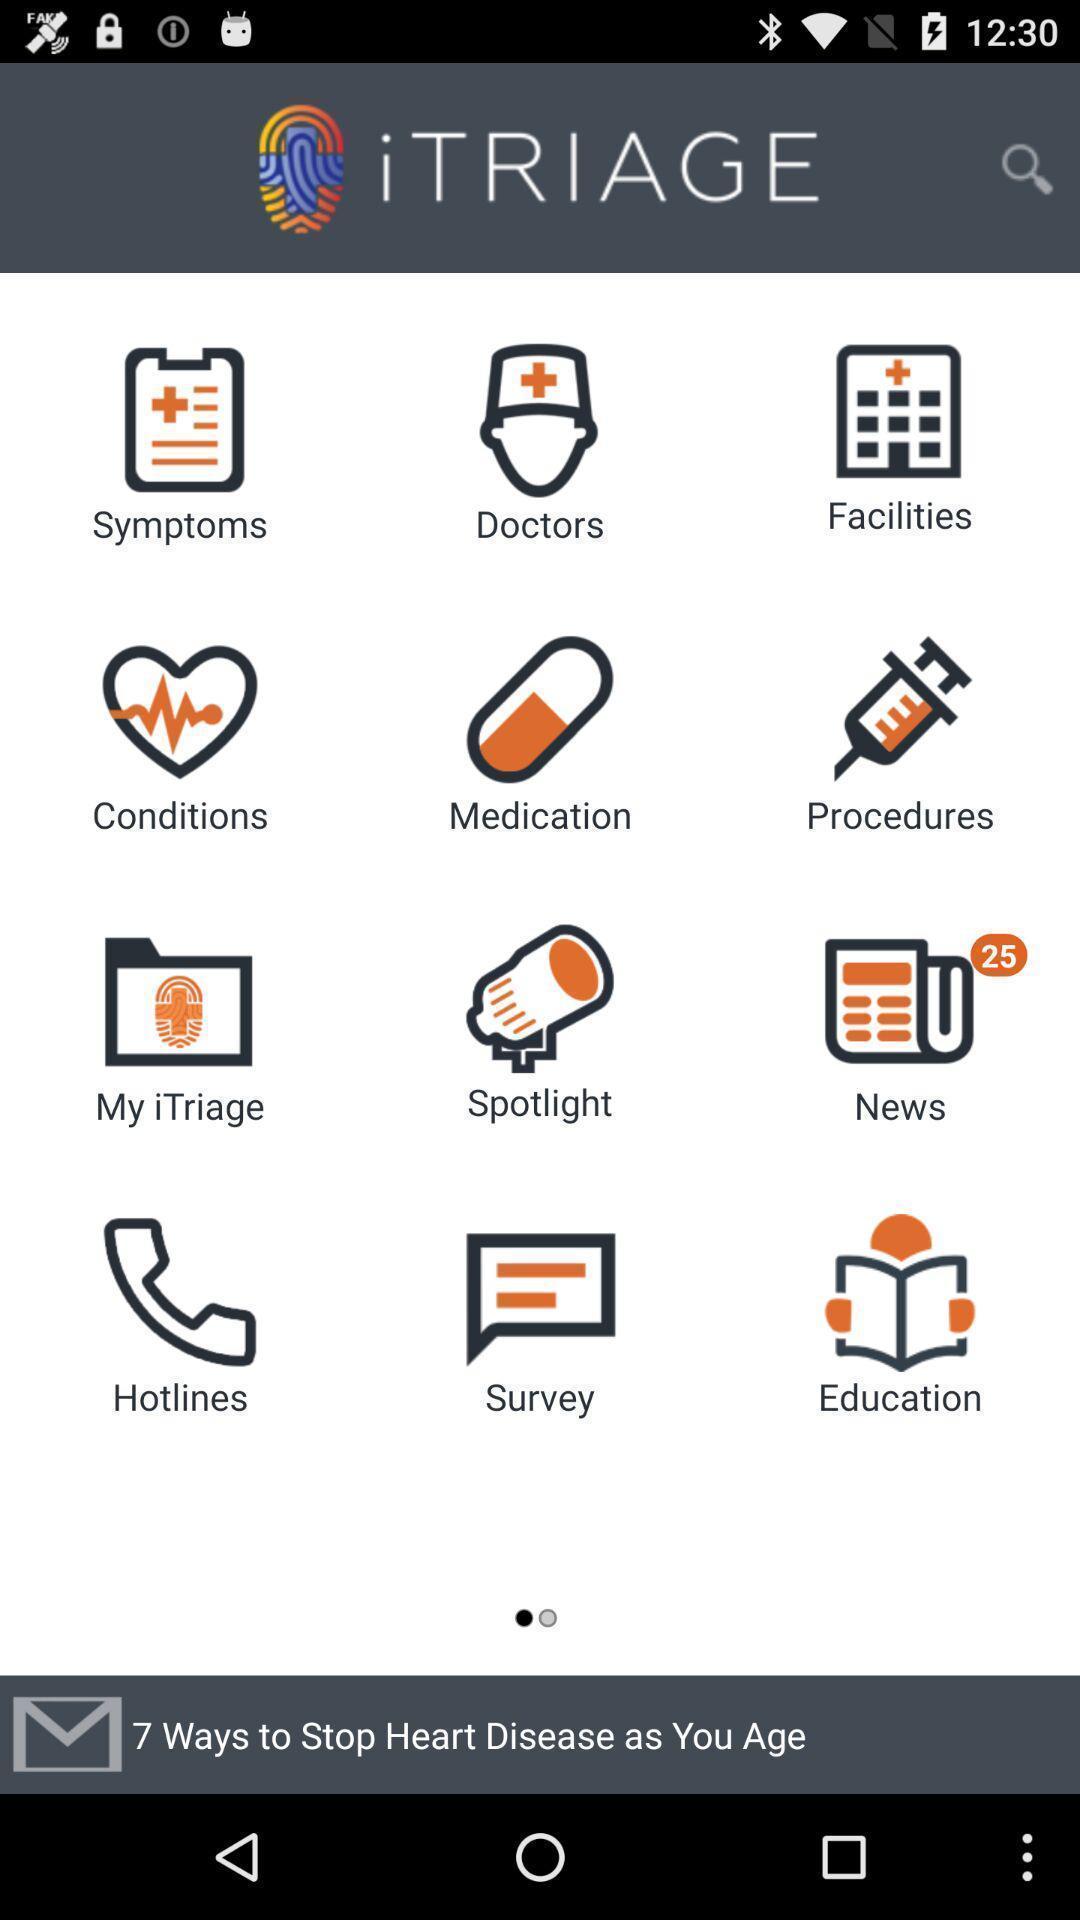Give me a summary of this screen capture. Page displaying multiple categories. 